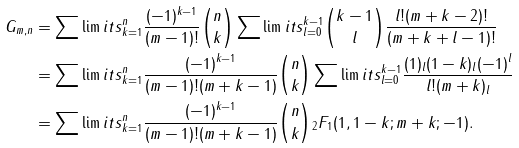<formula> <loc_0><loc_0><loc_500><loc_500>G _ { m , n } & = \sum \lim i t s _ { k = 1 } ^ { n } \frac { ( - 1 ) ^ { k - 1 } } { ( m - 1 ) ! } \binom { n } { k } \sum \lim i t s _ { l = 0 } ^ { k - 1 } \binom { k - 1 } { l } \frac { l ! ( m + k - 2 ) ! } { ( m + k + l - 1 ) ! } \\ & = \sum \lim i t s _ { k = 1 } ^ { n } \frac { ( - 1 ) ^ { k - 1 } } { ( m - 1 ) ! ( m + k - 1 ) } \binom { n } { k } \sum \lim i t s _ { l = 0 } ^ { k - 1 } \frac { ( 1 ) _ { l } ( 1 - k ) _ { l } ( - 1 ) ^ { l } } { l ! ( m + k ) _ { l } } \\ & = \sum \lim i t s _ { k = 1 } ^ { n } \frac { ( - 1 ) ^ { k - 1 } } { ( m - 1 ) ! ( m + k - 1 ) } \binom { n } { k } { _ { 2 } } F _ { 1 } ( 1 , 1 - k ; m + k ; - 1 ) .</formula> 